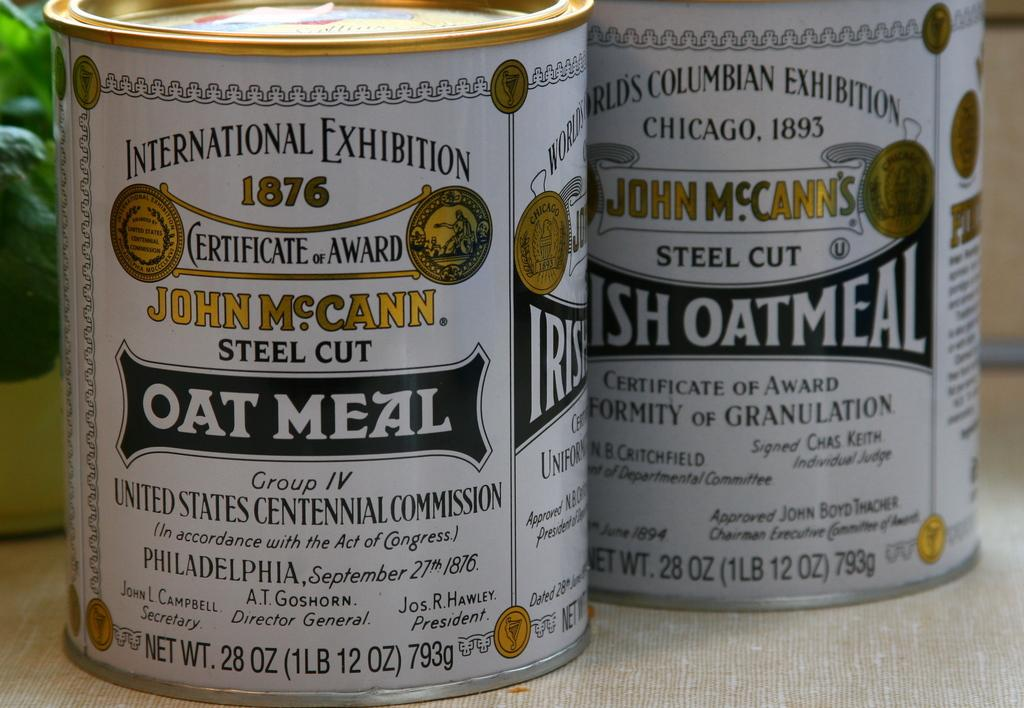How many bottles can be seen in the image? There are two bottles in the image. What can be found on the bottles? The bottles have text written on them. Where are the bottles located in the image? The bottles are on a surface and are visible in the middle of the image. What type of oil can be seen dripping from the lock in the image? There is no lock or oil present in the image. The image only features two bottles with text on them. 